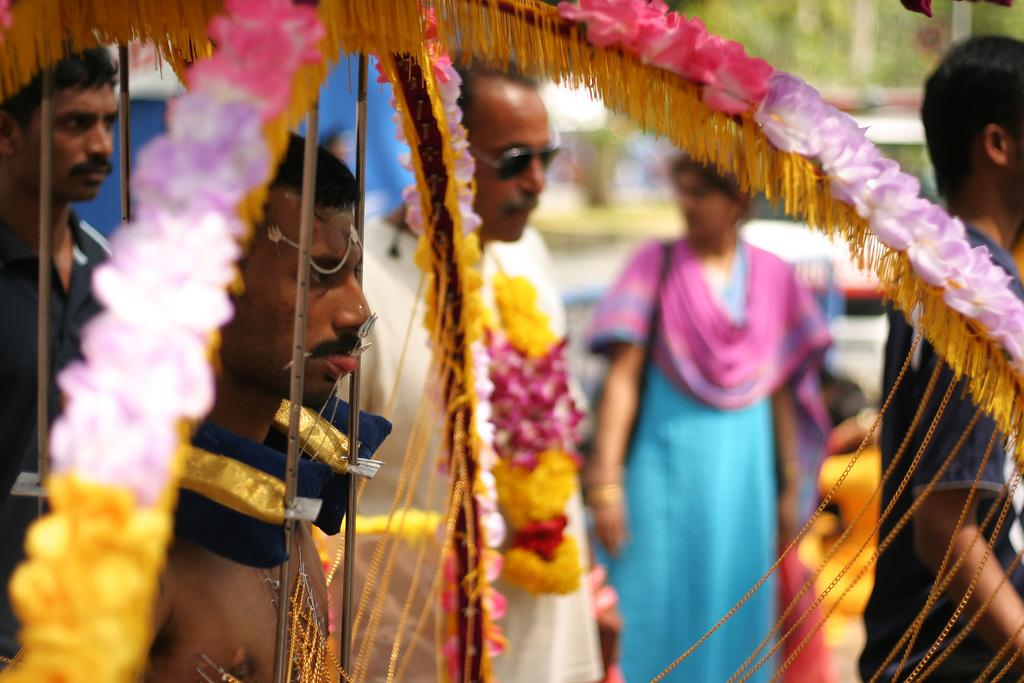Who or what can be seen in the image? There are people in the image. What else is present in the image besides the people? There is decoration in the image. Can you describe the object on the tongue of a man in the image? The object on the tongue of a man in the image is blurred in the background, so it cannot be clearly identified. What type of tin can be seen in the store at night in the image? There is no tin or store present in the image; it features people and decoration. 